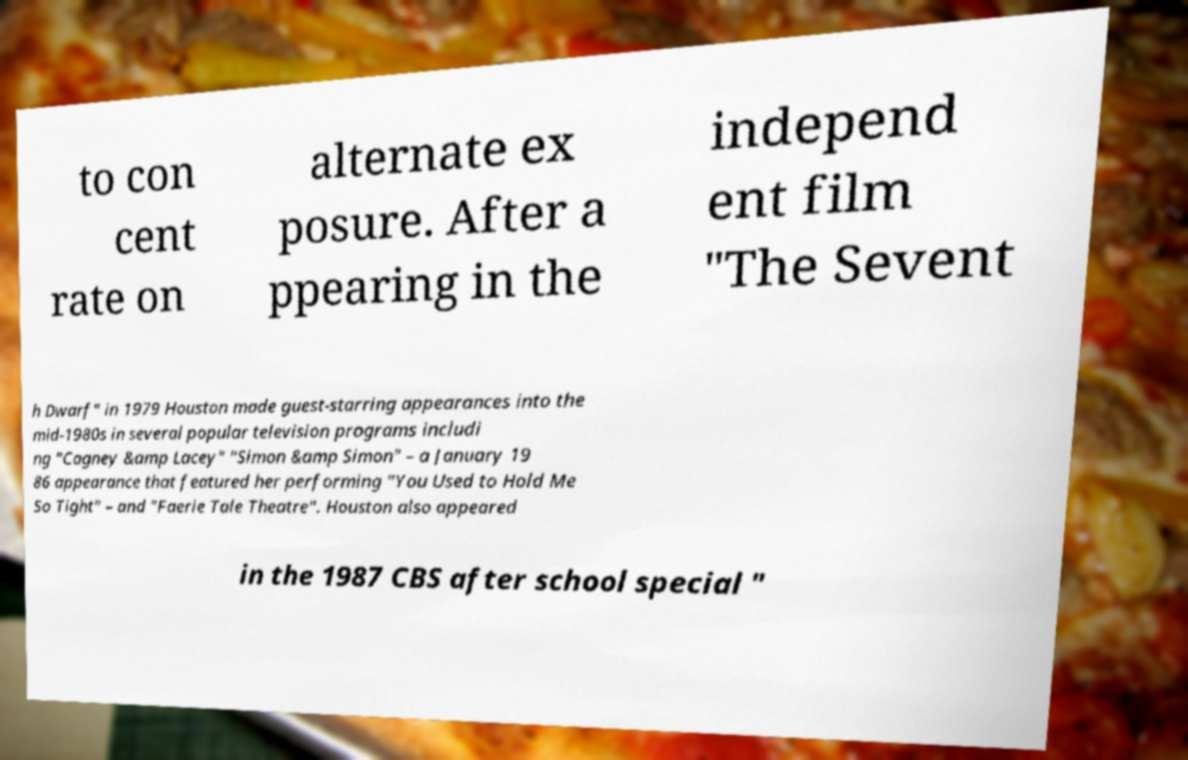Please identify and transcribe the text found in this image. to con cent rate on alternate ex posure. After a ppearing in the independ ent film "The Sevent h Dwarf" in 1979 Houston made guest-starring appearances into the mid-1980s in several popular television programs includi ng "Cagney &amp Lacey" "Simon &amp Simon" – a January 19 86 appearance that featured her performing "You Used to Hold Me So Tight" – and "Faerie Tale Theatre". Houston also appeared in the 1987 CBS after school special " 